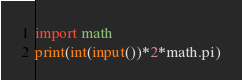<code> <loc_0><loc_0><loc_500><loc_500><_Python_>import math
print(int(input())*2*math.pi)</code> 